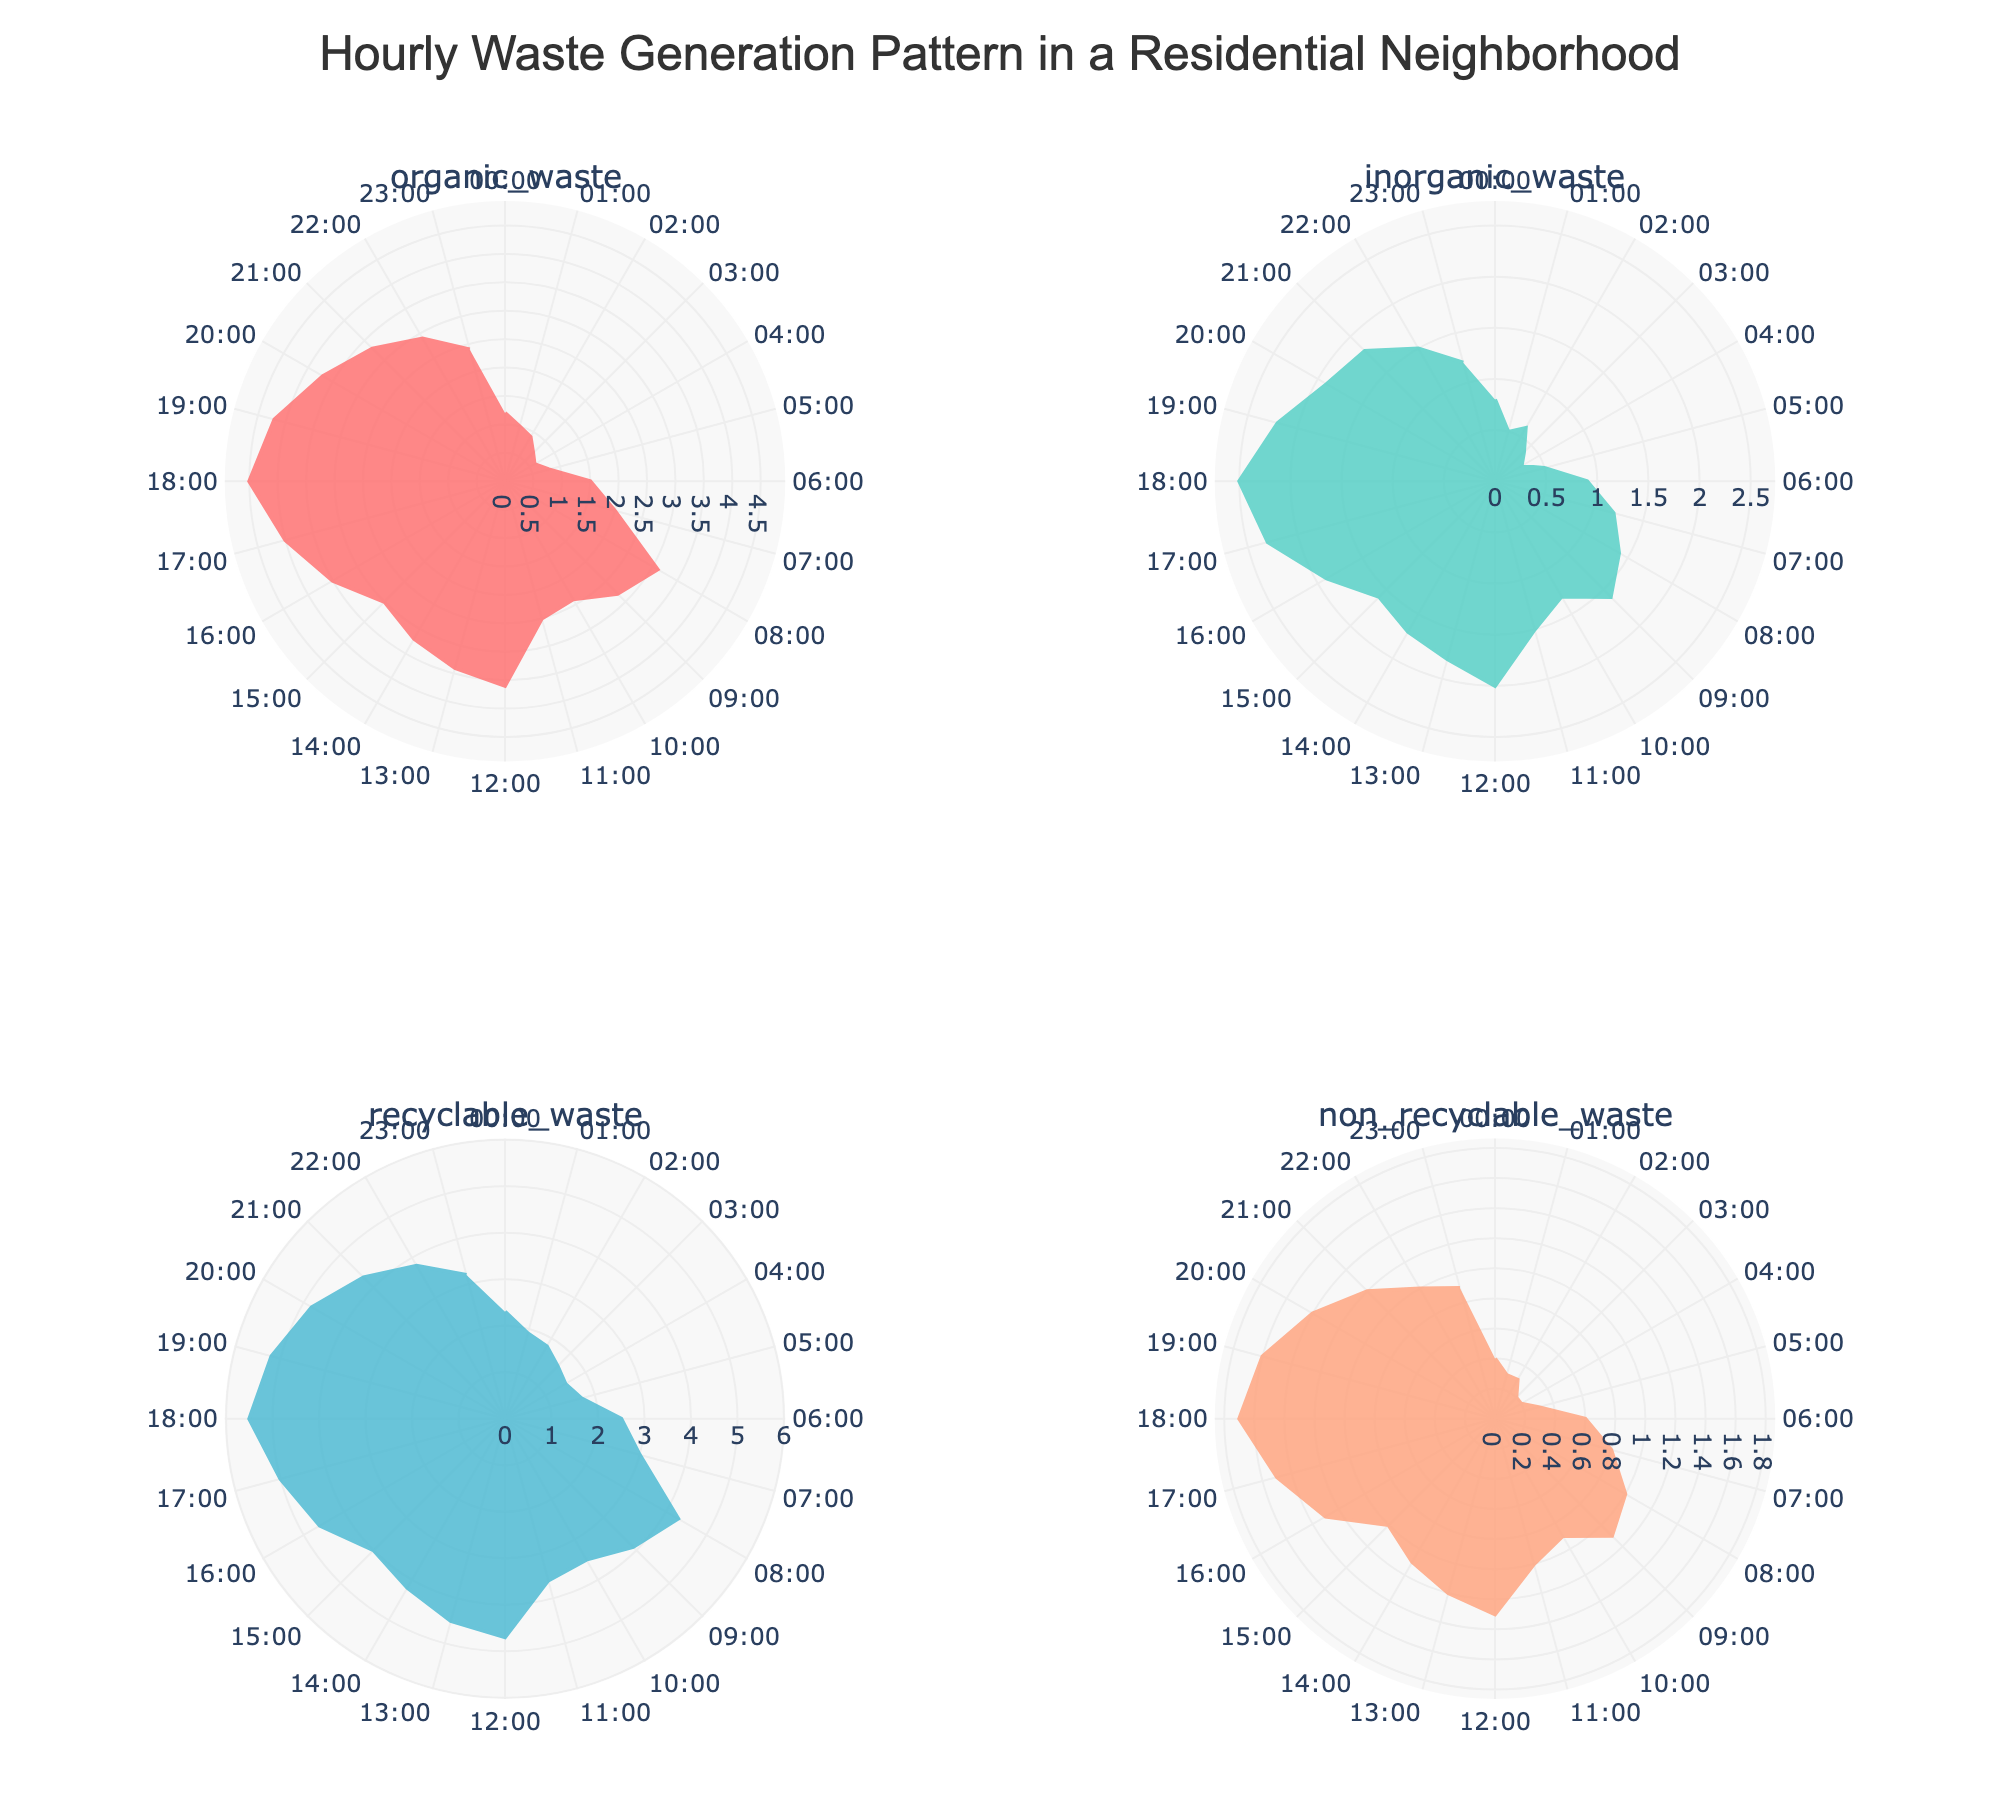What's the title of the chart? The title is usually found at the top of the chart. For this chart, it is "Hourly Waste Generation Pattern in a Residential Neighborhood".
Answer: Hourly Waste Generation Pattern in a Residential Neighborhood How many categories of waste are represented in the plot? The subplots' titles indicate the different categories of waste. There are four categories: organic waste, inorganic waste, recyclable waste, and non-recyclable waste.
Answer: Four Which category has the highest waste generation at 12:00-13:00? To identify the category with the highest waste generation at 12:00-13:00, examine the radial lengths for each subplot at this time. The category with the longest radius is recyclable waste.
Answer: Recyclable waste At what time does inorganic waste peak? Examine the polar chart for inorganic waste and identify the time with the longest radial length. The peak occurs at 18:00-19:00.
Answer: 18:00-19:00 Is there a category where waste generation remains relatively low throughout the day? Compare the radial lengths for each waste category across all hours. The non-recyclable waste category has relatively low values throughout.
Answer: Non-recyclable waste What is the difference in organic waste generation between 08:00-09:00 and 12:00-13:00? From the organic waste plot, read the values at 08:00-09:00 and 12:00-13:00, which are 3.1 and 3.6 tons respectively. Their difference is 0.5 tons.
Answer: 0.5 tons What is the average hourly generation of recyclable waste? To find the average, sum the hourly values of recyclable waste and divide by the number of hours. The sum is 79.5, and there are 24 hours, so the average is 79.5 / 24 = 3.31.
Answer: 3.31 Which two categories have the closest values at 18:00-19:00? Compare the radial lengths for each category at 18:00-19:00. Inorganic waste (2.5 tons) and non-recyclable waste (1.7 tons) have the closest values.
Answer: Inorganic waste and non-recyclable waste How does the pattern of organic waste generation compare to that of recyclable waste? Compare the shapes and peaks of the polar charts for organic waste and recyclable waste. Both have peaks around the same times but recyclable waste generally has higher values.
Answer: Similar peaks, but recyclable waste is generally higher 